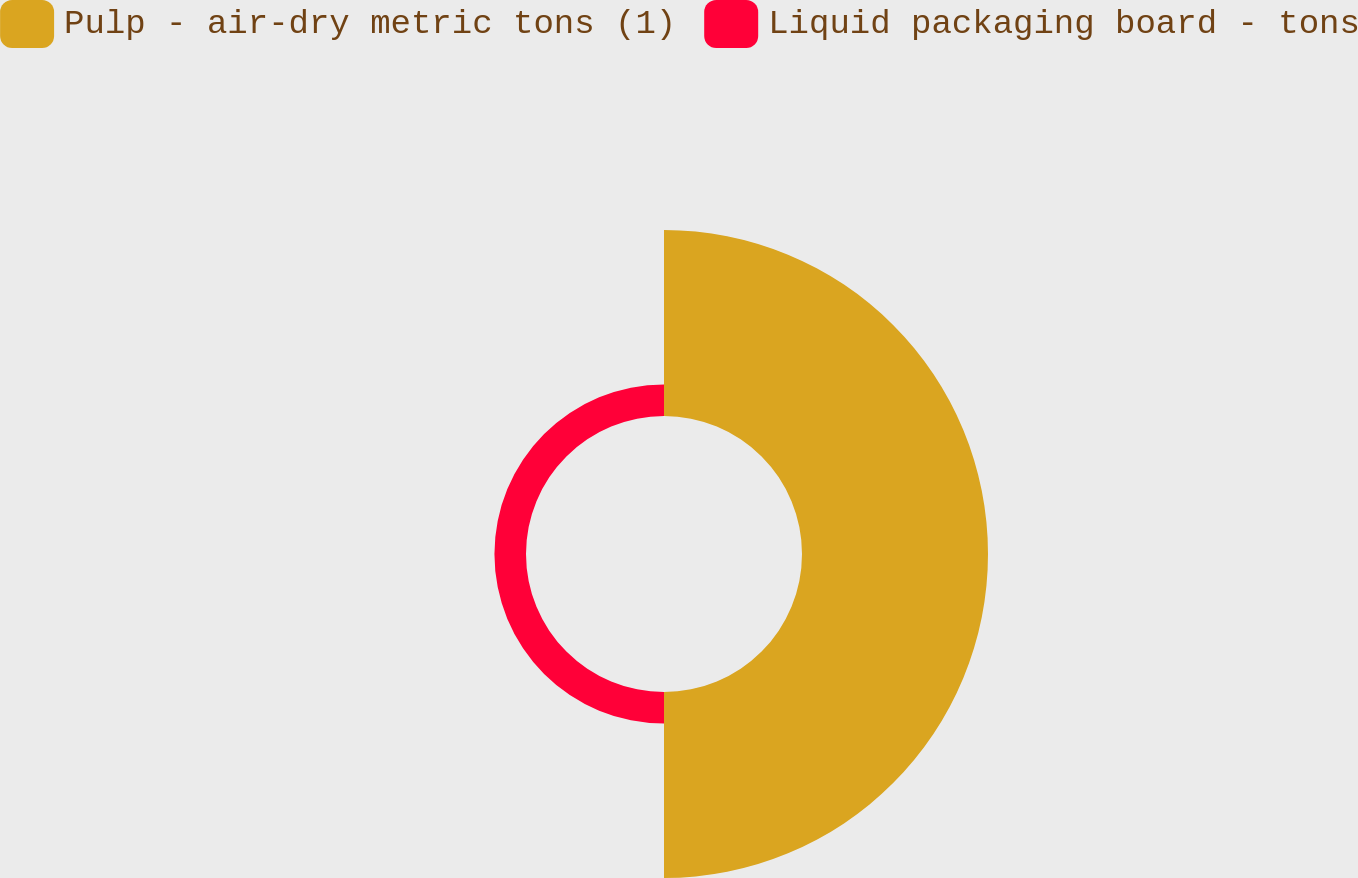Convert chart. <chart><loc_0><loc_0><loc_500><loc_500><pie_chart><fcel>Pulp - air-dry metric tons (1)<fcel>Liquid packaging board - tons<nl><fcel>85.49%<fcel>14.51%<nl></chart> 